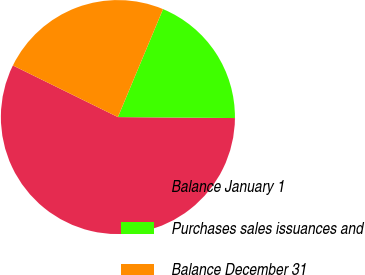Convert chart. <chart><loc_0><loc_0><loc_500><loc_500><pie_chart><fcel>Balance January 1<fcel>Purchases sales issuances and<fcel>Balance December 31<nl><fcel>57.14%<fcel>18.83%<fcel>24.03%<nl></chart> 